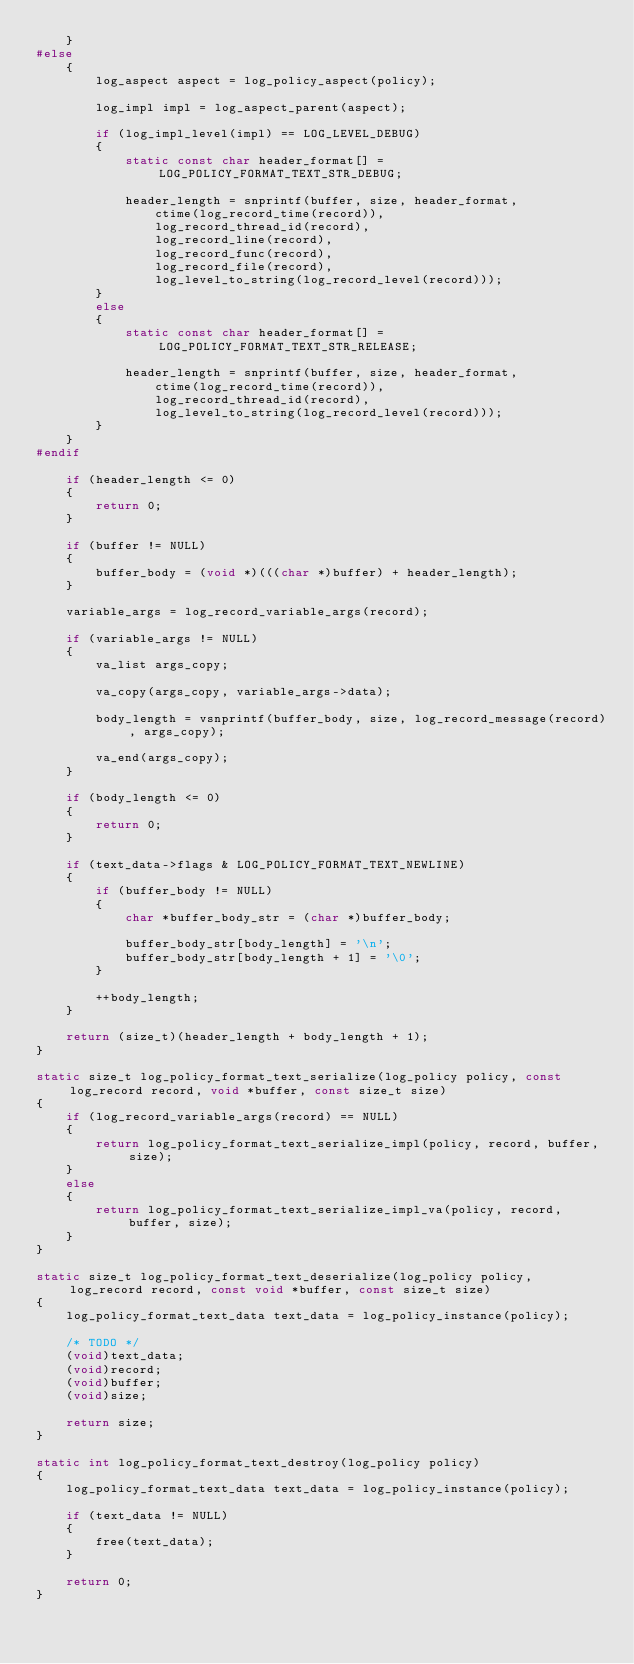<code> <loc_0><loc_0><loc_500><loc_500><_C_>	}
#else
	{
		log_aspect aspect = log_policy_aspect(policy);

		log_impl impl = log_aspect_parent(aspect);

		if (log_impl_level(impl) == LOG_LEVEL_DEBUG)
		{
			static const char header_format[] = LOG_POLICY_FORMAT_TEXT_STR_DEBUG;

			header_length = snprintf(buffer, size, header_format,
				ctime(log_record_time(record)),
				log_record_thread_id(record),
				log_record_line(record),
				log_record_func(record),
				log_record_file(record),
				log_level_to_string(log_record_level(record)));
		}
		else
		{
			static const char header_format[] = LOG_POLICY_FORMAT_TEXT_STR_RELEASE;

			header_length = snprintf(buffer, size, header_format,
				ctime(log_record_time(record)),
				log_record_thread_id(record),
				log_level_to_string(log_record_level(record)));
		}
	}
#endif

	if (header_length <= 0)
	{
		return 0;
	}

	if (buffer != NULL)
	{
		buffer_body = (void *)(((char *)buffer) + header_length);
	}

	variable_args = log_record_variable_args(record);

	if (variable_args != NULL)
	{
		va_list args_copy;

		va_copy(args_copy, variable_args->data);

		body_length = vsnprintf(buffer_body, size, log_record_message(record), args_copy);

		va_end(args_copy);
	}

	if (body_length <= 0)
	{
		return 0;
	}

	if (text_data->flags & LOG_POLICY_FORMAT_TEXT_NEWLINE)
	{
		if (buffer_body != NULL)
		{
			char *buffer_body_str = (char *)buffer_body;

			buffer_body_str[body_length] = '\n';
			buffer_body_str[body_length + 1] = '\0';
		}

		++body_length;
	}

	return (size_t)(header_length + body_length + 1);
}

static size_t log_policy_format_text_serialize(log_policy policy, const log_record record, void *buffer, const size_t size)
{
	if (log_record_variable_args(record) == NULL)
	{
		return log_policy_format_text_serialize_impl(policy, record, buffer, size);
	}
	else
	{
		return log_policy_format_text_serialize_impl_va(policy, record, buffer, size);
	}
}

static size_t log_policy_format_text_deserialize(log_policy policy, log_record record, const void *buffer, const size_t size)
{
	log_policy_format_text_data text_data = log_policy_instance(policy);

	/* TODO */
	(void)text_data;
	(void)record;
	(void)buffer;
	(void)size;

	return size;
}

static int log_policy_format_text_destroy(log_policy policy)
{
	log_policy_format_text_data text_data = log_policy_instance(policy);

	if (text_data != NULL)
	{
		free(text_data);
	}

	return 0;
}
</code> 